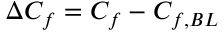<formula> <loc_0><loc_0><loc_500><loc_500>\Delta C _ { f } = C _ { f } - C _ { f , B L }</formula> 